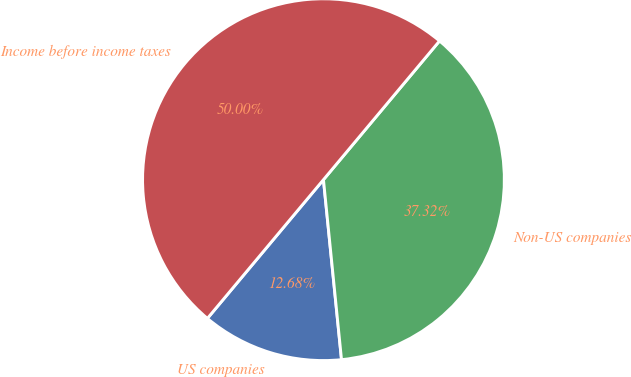Convert chart to OTSL. <chart><loc_0><loc_0><loc_500><loc_500><pie_chart><fcel>US companies<fcel>Non-US companies<fcel>Income before income taxes<nl><fcel>12.68%<fcel>37.32%<fcel>50.0%<nl></chart> 